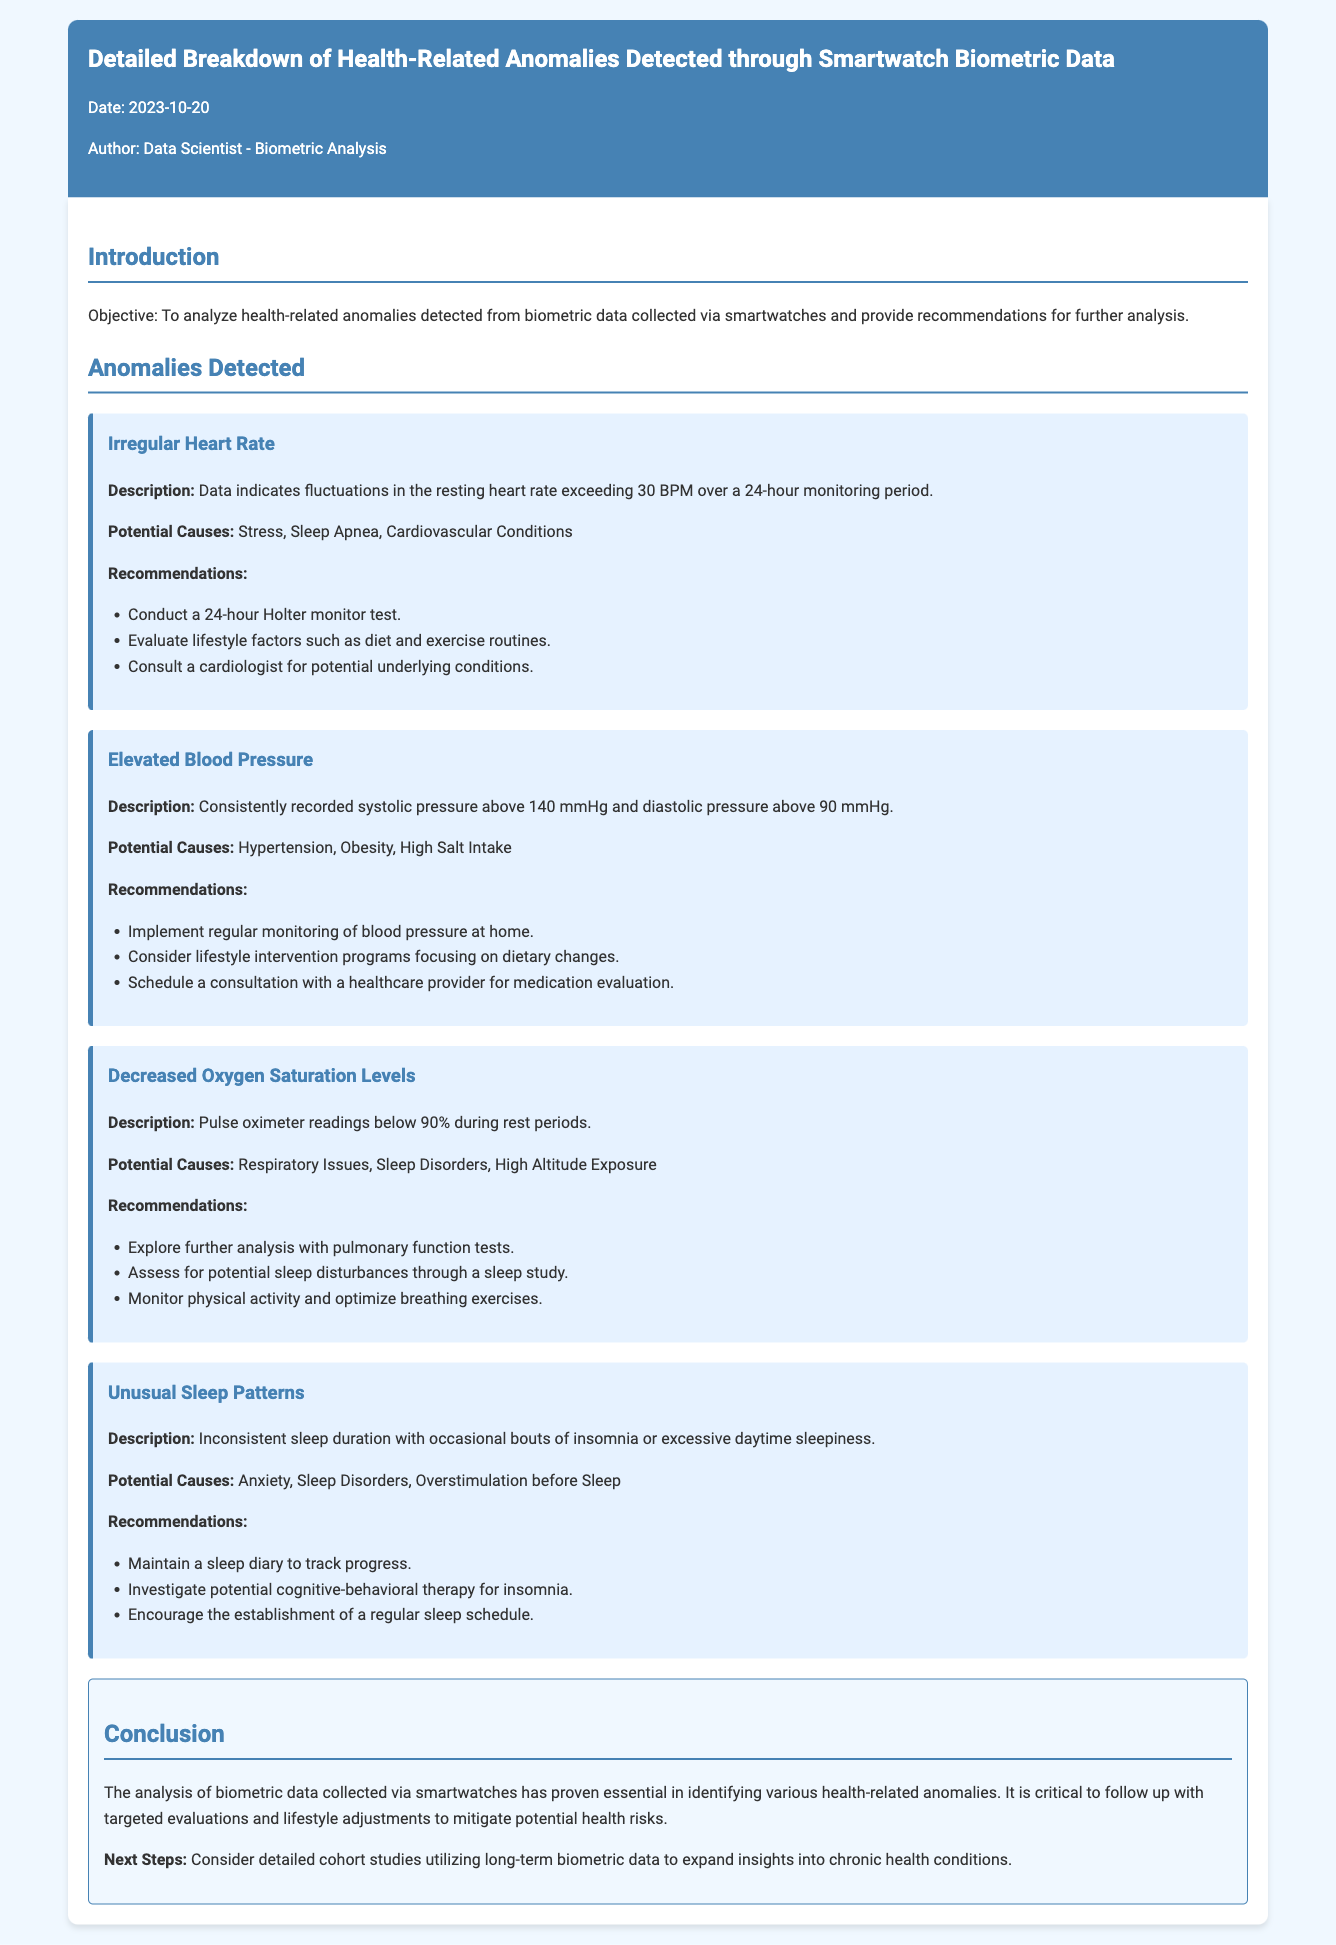What is the date of the memo? The date of the memo is stated in the header section of the document.
Answer: 2023-10-20 Who is the author of the memo? The author of the memo is mentioned in the header of the document.
Answer: Data Scientist - Biometric Analysis What is the objective of the analysis? The objective is specified in the introduction section of the document, outlining the purpose of the analysis.
Answer: To analyze health-related anomalies What is the description of Irregular Heart Rate anomaly? The description is provided under the Irregular Heart Rate section, summarizing the anomaly's characteristics.
Answer: Fluctuations in the resting heart rate exceeding 30 BPM What is a potential cause of Elevated Blood Pressure? The document lists potential causes under the Elevated Blood Pressure anomaly section.
Answer: Hypertension What recommendation is given for Decreased Oxygen Saturation Levels? A specific recommendation is included for this anomaly in the corresponding section.
Answer: Explore further analysis with pulmonary function tests How should unusual sleep patterns be tracked? The document provides recommendations for tracking in the Unusual Sleep Patterns section.
Answer: Maintain a sleep diary What is the critical takeaway from the conclusion? The conclusion includes a summary about the importance of biometric data in identifying health anomalies.
Answer: Follow up with targeted evaluations What are the next steps mentioned in the conclusion? The next steps are detailed at the end of the conclusion, suggesting further research directions.
Answer: Consider detailed cohort studies 